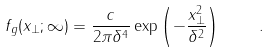Convert formula to latex. <formula><loc_0><loc_0><loc_500><loc_500>f _ { g } ( x _ { \perp } ; \infty ) = \frac { c } { 2 \pi \delta ^ { 4 } } \exp \left ( - \frac { x _ { \perp } ^ { 2 } } { \delta ^ { 2 } } \right ) \quad .</formula> 